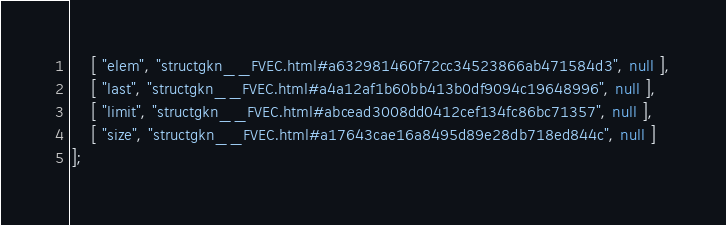<code> <loc_0><loc_0><loc_500><loc_500><_JavaScript_>    [ "elem", "structgkn__FVEC.html#a632981460f72cc34523866ab471584d3", null ],
    [ "last", "structgkn__FVEC.html#a4a12af1b60bb413b0df9094c19648996", null ],
    [ "limit", "structgkn__FVEC.html#abcead3008dd0412cef134fc86bc71357", null ],
    [ "size", "structgkn__FVEC.html#a17643cae16a8495d89e28db718ed844c", null ]
];</code> 